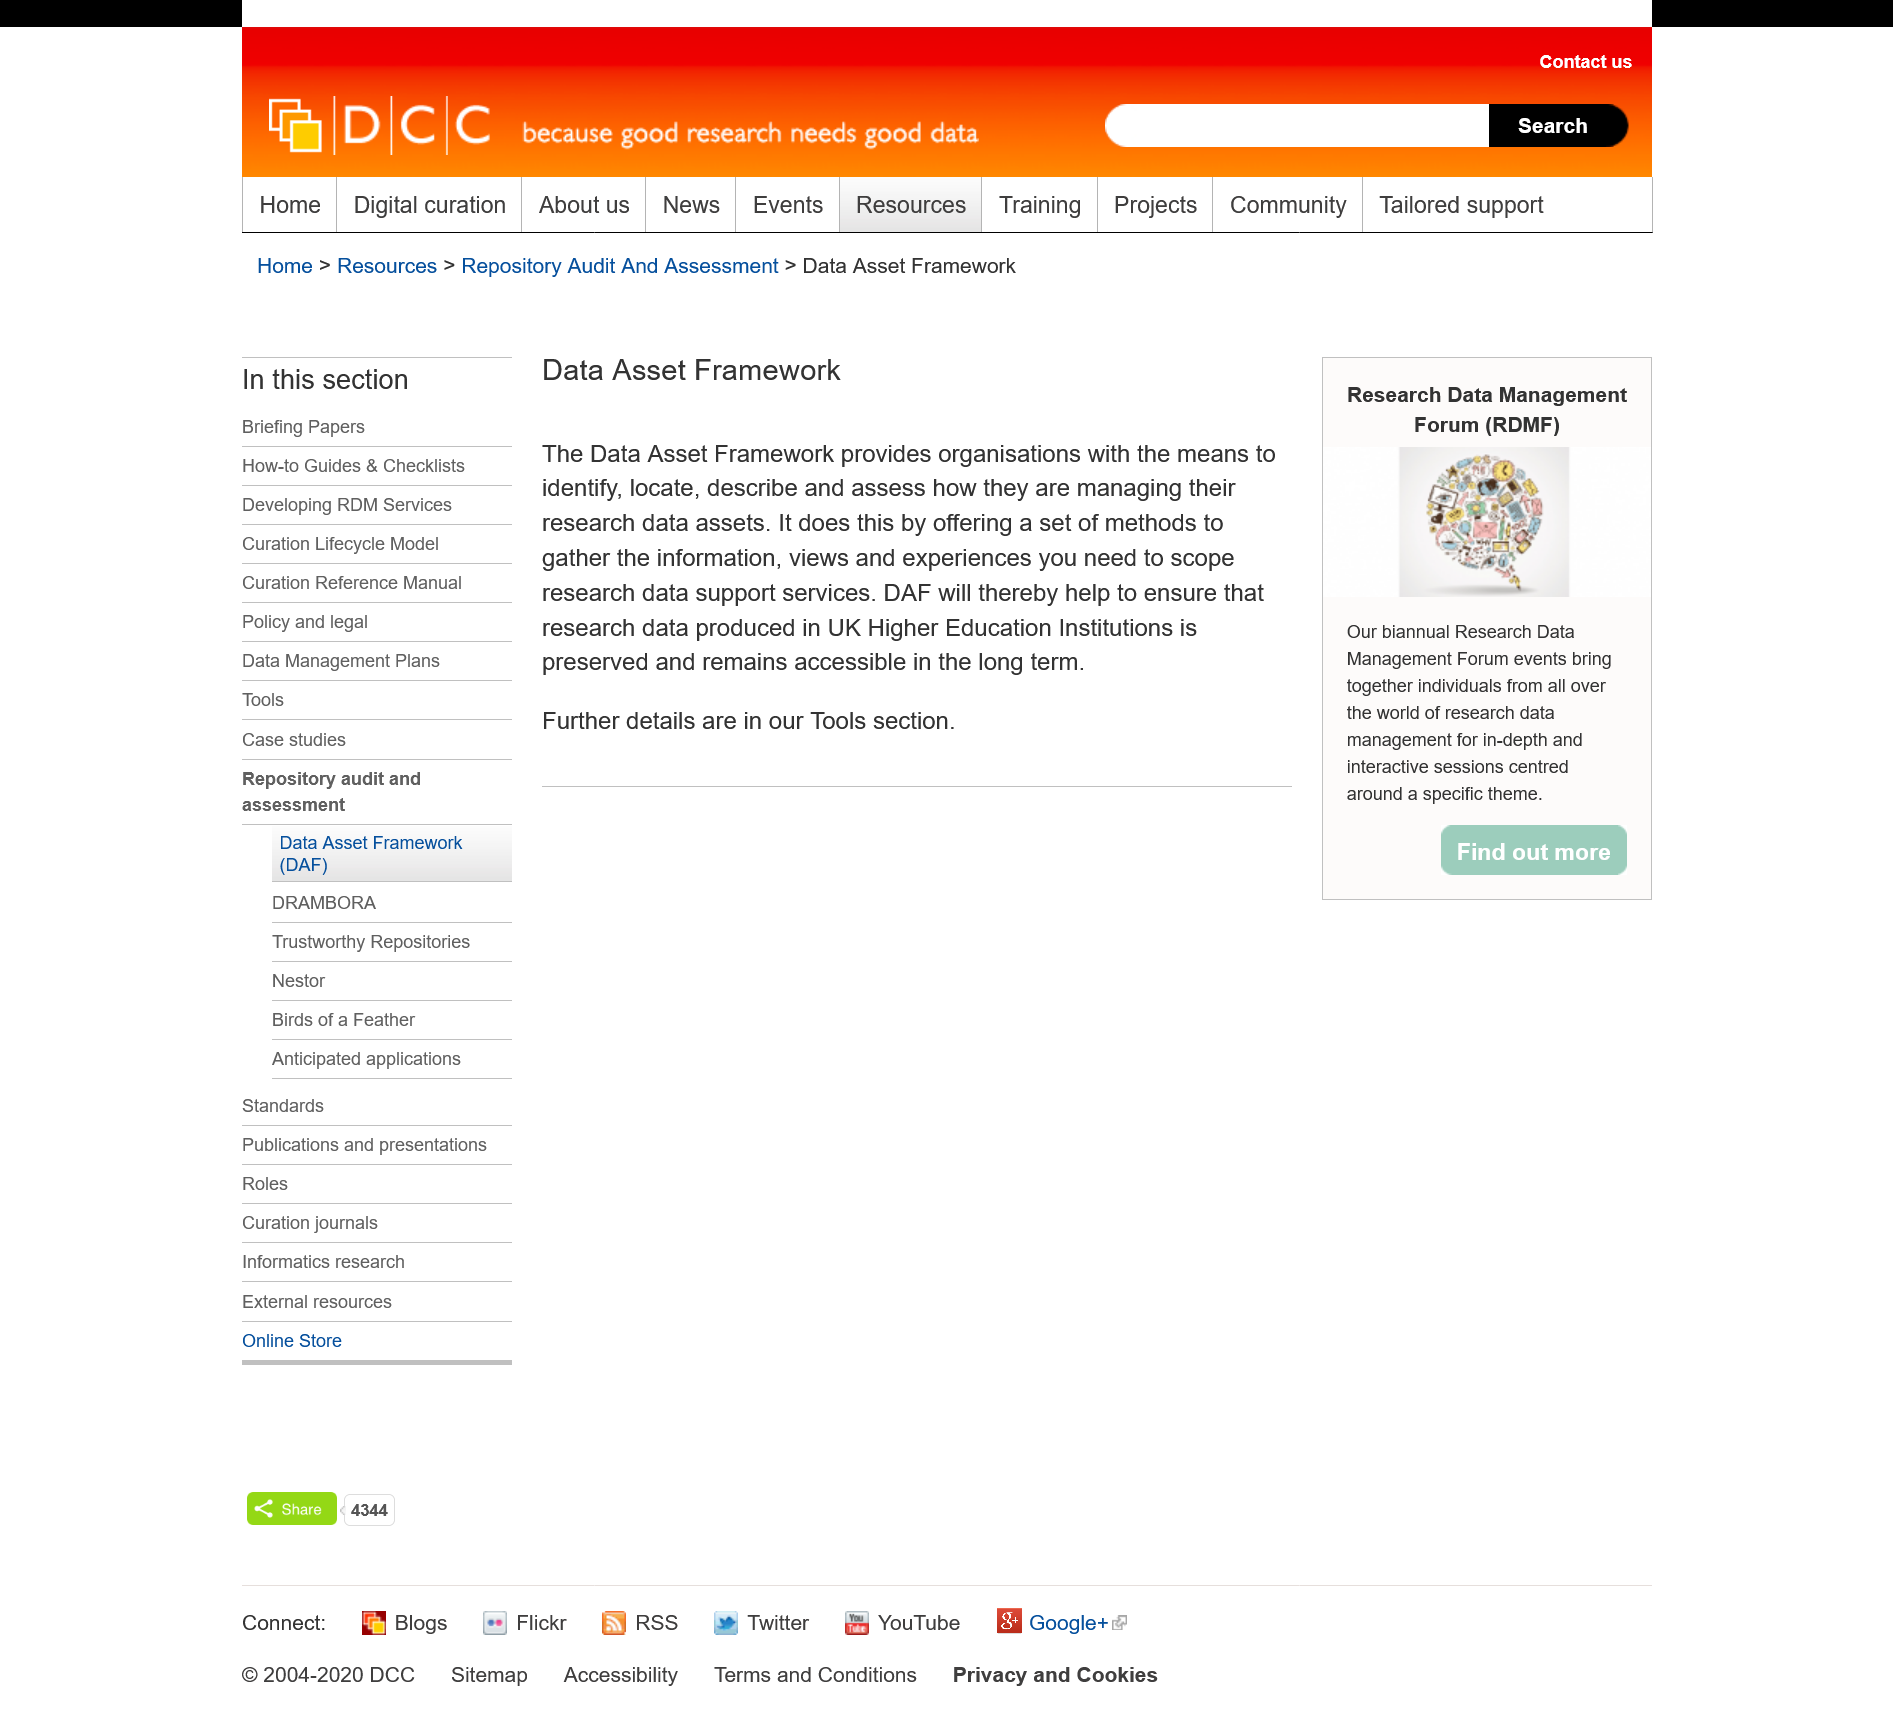Draw attention to some important aspects in this diagram. The Data Asset Framework provides a set of methods for gathering information, views, and experiences necessary to scope research data support services. The acronym "DAF" stands for "Data Asset Framework." It is a reference to a specific system or structure designed to manage and organize data assets. The Data Asset Framework further details can be found in the Tools section. 